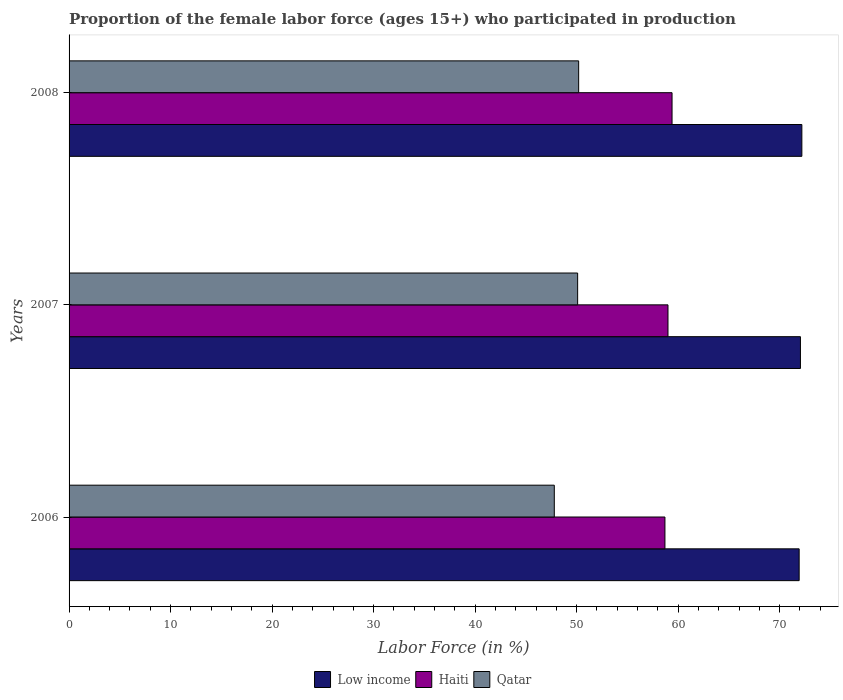How many different coloured bars are there?
Your response must be concise. 3. How many groups of bars are there?
Your response must be concise. 3. Are the number of bars per tick equal to the number of legend labels?
Your answer should be compact. Yes. How many bars are there on the 3rd tick from the top?
Ensure brevity in your answer.  3. What is the label of the 3rd group of bars from the top?
Your answer should be very brief. 2006. In how many cases, is the number of bars for a given year not equal to the number of legend labels?
Offer a terse response. 0. What is the proportion of the female labor force who participated in production in Haiti in 2007?
Your answer should be very brief. 59. Across all years, what is the maximum proportion of the female labor force who participated in production in Qatar?
Offer a terse response. 50.2. Across all years, what is the minimum proportion of the female labor force who participated in production in Qatar?
Your answer should be compact. 47.8. In which year was the proportion of the female labor force who participated in production in Haiti maximum?
Give a very brief answer. 2008. In which year was the proportion of the female labor force who participated in production in Qatar minimum?
Your answer should be compact. 2006. What is the total proportion of the female labor force who participated in production in Haiti in the graph?
Make the answer very short. 177.1. What is the difference between the proportion of the female labor force who participated in production in Low income in 2006 and that in 2008?
Offer a terse response. -0.27. What is the difference between the proportion of the female labor force who participated in production in Low income in 2006 and the proportion of the female labor force who participated in production in Haiti in 2007?
Keep it short and to the point. 12.92. What is the average proportion of the female labor force who participated in production in Haiti per year?
Your response must be concise. 59.03. In the year 2006, what is the difference between the proportion of the female labor force who participated in production in Low income and proportion of the female labor force who participated in production in Haiti?
Give a very brief answer. 13.22. In how many years, is the proportion of the female labor force who participated in production in Qatar greater than 60 %?
Your answer should be very brief. 0. What is the ratio of the proportion of the female labor force who participated in production in Low income in 2007 to that in 2008?
Keep it short and to the point. 1. Is the proportion of the female labor force who participated in production in Qatar in 2006 less than that in 2007?
Your answer should be compact. Yes. Is the difference between the proportion of the female labor force who participated in production in Low income in 2006 and 2007 greater than the difference between the proportion of the female labor force who participated in production in Haiti in 2006 and 2007?
Keep it short and to the point. Yes. What is the difference between the highest and the second highest proportion of the female labor force who participated in production in Haiti?
Your response must be concise. 0.4. What is the difference between the highest and the lowest proportion of the female labor force who participated in production in Low income?
Provide a short and direct response. 0.27. Is the sum of the proportion of the female labor force who participated in production in Low income in 2006 and 2008 greater than the maximum proportion of the female labor force who participated in production in Qatar across all years?
Offer a very short reply. Yes. What does the 2nd bar from the top in 2008 represents?
Give a very brief answer. Haiti. What does the 2nd bar from the bottom in 2006 represents?
Keep it short and to the point. Haiti. How many bars are there?
Provide a succinct answer. 9. How many years are there in the graph?
Your answer should be very brief. 3. What is the difference between two consecutive major ticks on the X-axis?
Give a very brief answer. 10. Are the values on the major ticks of X-axis written in scientific E-notation?
Offer a terse response. No. How many legend labels are there?
Your response must be concise. 3. What is the title of the graph?
Offer a very short reply. Proportion of the female labor force (ages 15+) who participated in production. What is the label or title of the X-axis?
Provide a succinct answer. Labor Force (in %). What is the label or title of the Y-axis?
Give a very brief answer. Years. What is the Labor Force (in %) of Low income in 2006?
Your response must be concise. 71.92. What is the Labor Force (in %) of Haiti in 2006?
Give a very brief answer. 58.7. What is the Labor Force (in %) in Qatar in 2006?
Provide a short and direct response. 47.8. What is the Labor Force (in %) of Low income in 2007?
Provide a short and direct response. 72.05. What is the Labor Force (in %) of Qatar in 2007?
Make the answer very short. 50.1. What is the Labor Force (in %) of Low income in 2008?
Your answer should be compact. 72.19. What is the Labor Force (in %) of Haiti in 2008?
Your response must be concise. 59.4. What is the Labor Force (in %) of Qatar in 2008?
Provide a short and direct response. 50.2. Across all years, what is the maximum Labor Force (in %) of Low income?
Ensure brevity in your answer.  72.19. Across all years, what is the maximum Labor Force (in %) in Haiti?
Your answer should be compact. 59.4. Across all years, what is the maximum Labor Force (in %) of Qatar?
Your answer should be very brief. 50.2. Across all years, what is the minimum Labor Force (in %) in Low income?
Your answer should be compact. 71.92. Across all years, what is the minimum Labor Force (in %) of Haiti?
Your response must be concise. 58.7. Across all years, what is the minimum Labor Force (in %) in Qatar?
Your response must be concise. 47.8. What is the total Labor Force (in %) of Low income in the graph?
Make the answer very short. 216.16. What is the total Labor Force (in %) of Haiti in the graph?
Make the answer very short. 177.1. What is the total Labor Force (in %) of Qatar in the graph?
Provide a succinct answer. 148.1. What is the difference between the Labor Force (in %) of Low income in 2006 and that in 2007?
Make the answer very short. -0.13. What is the difference between the Labor Force (in %) in Qatar in 2006 and that in 2007?
Your response must be concise. -2.3. What is the difference between the Labor Force (in %) in Low income in 2006 and that in 2008?
Offer a very short reply. -0.27. What is the difference between the Labor Force (in %) in Haiti in 2006 and that in 2008?
Your answer should be very brief. -0.7. What is the difference between the Labor Force (in %) of Low income in 2007 and that in 2008?
Offer a very short reply. -0.14. What is the difference between the Labor Force (in %) in Low income in 2006 and the Labor Force (in %) in Haiti in 2007?
Your answer should be very brief. 12.92. What is the difference between the Labor Force (in %) in Low income in 2006 and the Labor Force (in %) in Qatar in 2007?
Provide a short and direct response. 21.82. What is the difference between the Labor Force (in %) of Low income in 2006 and the Labor Force (in %) of Haiti in 2008?
Offer a terse response. 12.52. What is the difference between the Labor Force (in %) of Low income in 2006 and the Labor Force (in %) of Qatar in 2008?
Make the answer very short. 21.72. What is the difference between the Labor Force (in %) in Low income in 2007 and the Labor Force (in %) in Haiti in 2008?
Make the answer very short. 12.65. What is the difference between the Labor Force (in %) of Low income in 2007 and the Labor Force (in %) of Qatar in 2008?
Provide a succinct answer. 21.85. What is the difference between the Labor Force (in %) of Haiti in 2007 and the Labor Force (in %) of Qatar in 2008?
Provide a succinct answer. 8.8. What is the average Labor Force (in %) in Low income per year?
Provide a short and direct response. 72.05. What is the average Labor Force (in %) of Haiti per year?
Offer a terse response. 59.03. What is the average Labor Force (in %) of Qatar per year?
Your response must be concise. 49.37. In the year 2006, what is the difference between the Labor Force (in %) in Low income and Labor Force (in %) in Haiti?
Your answer should be compact. 13.22. In the year 2006, what is the difference between the Labor Force (in %) of Low income and Labor Force (in %) of Qatar?
Make the answer very short. 24.12. In the year 2006, what is the difference between the Labor Force (in %) of Haiti and Labor Force (in %) of Qatar?
Provide a succinct answer. 10.9. In the year 2007, what is the difference between the Labor Force (in %) in Low income and Labor Force (in %) in Haiti?
Provide a succinct answer. 13.05. In the year 2007, what is the difference between the Labor Force (in %) of Low income and Labor Force (in %) of Qatar?
Your answer should be compact. 21.95. In the year 2008, what is the difference between the Labor Force (in %) in Low income and Labor Force (in %) in Haiti?
Your response must be concise. 12.79. In the year 2008, what is the difference between the Labor Force (in %) of Low income and Labor Force (in %) of Qatar?
Offer a terse response. 21.99. What is the ratio of the Labor Force (in %) of Low income in 2006 to that in 2007?
Give a very brief answer. 1. What is the ratio of the Labor Force (in %) of Qatar in 2006 to that in 2007?
Provide a short and direct response. 0.95. What is the ratio of the Labor Force (in %) of Haiti in 2006 to that in 2008?
Offer a very short reply. 0.99. What is the ratio of the Labor Force (in %) in Qatar in 2006 to that in 2008?
Offer a terse response. 0.95. What is the ratio of the Labor Force (in %) in Qatar in 2007 to that in 2008?
Your answer should be very brief. 1. What is the difference between the highest and the second highest Labor Force (in %) of Low income?
Make the answer very short. 0.14. What is the difference between the highest and the second highest Labor Force (in %) in Haiti?
Your answer should be compact. 0.4. What is the difference between the highest and the lowest Labor Force (in %) of Low income?
Ensure brevity in your answer.  0.27. What is the difference between the highest and the lowest Labor Force (in %) in Qatar?
Your answer should be compact. 2.4. 